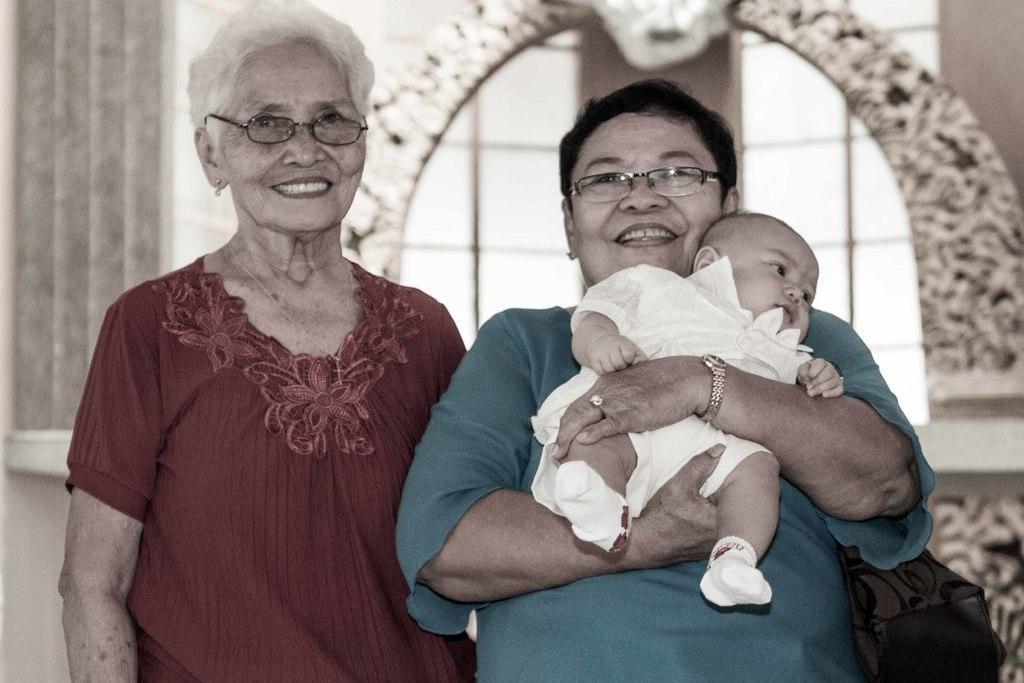How would you summarize this image in a sentence or two? In this image there are two persons standing and smiling, a person carrying a baby , and there is blur background. 